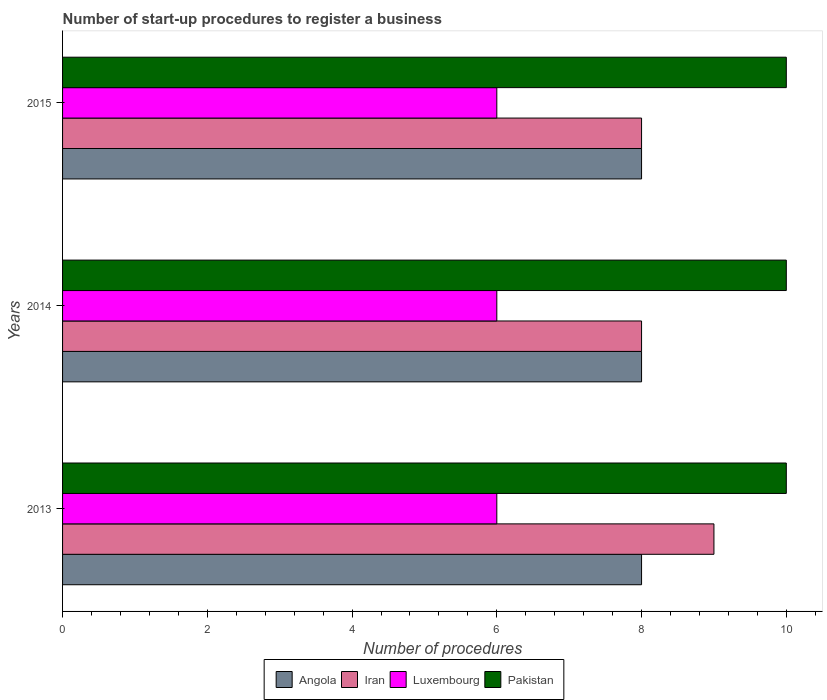How many different coloured bars are there?
Keep it short and to the point. 4. Are the number of bars per tick equal to the number of legend labels?
Your answer should be very brief. Yes. Are the number of bars on each tick of the Y-axis equal?
Offer a terse response. Yes. How many bars are there on the 3rd tick from the top?
Offer a terse response. 4. How many bars are there on the 3rd tick from the bottom?
Make the answer very short. 4. What is the number of procedures required to register a business in Angola in 2013?
Your answer should be compact. 8. Across all years, what is the maximum number of procedures required to register a business in Iran?
Give a very brief answer. 9. Across all years, what is the minimum number of procedures required to register a business in Angola?
Make the answer very short. 8. In which year was the number of procedures required to register a business in Iran maximum?
Your answer should be very brief. 2013. What is the total number of procedures required to register a business in Pakistan in the graph?
Your response must be concise. 30. What is the difference between the number of procedures required to register a business in Angola in 2013 and the number of procedures required to register a business in Pakistan in 2015?
Provide a succinct answer. -2. What is the average number of procedures required to register a business in Angola per year?
Your answer should be compact. 8. In the year 2015, what is the difference between the number of procedures required to register a business in Iran and number of procedures required to register a business in Angola?
Give a very brief answer. 0. In how many years, is the number of procedures required to register a business in Luxembourg greater than 6.8 ?
Your answer should be very brief. 0. Is the number of procedures required to register a business in Angola in 2013 less than that in 2014?
Offer a very short reply. No. What is the difference between the highest and the lowest number of procedures required to register a business in Iran?
Offer a terse response. 1. In how many years, is the number of procedures required to register a business in Angola greater than the average number of procedures required to register a business in Angola taken over all years?
Give a very brief answer. 0. Is the sum of the number of procedures required to register a business in Iran in 2013 and 2014 greater than the maximum number of procedures required to register a business in Luxembourg across all years?
Provide a short and direct response. Yes. What does the 3rd bar from the top in 2015 represents?
Provide a short and direct response. Iran. What does the 3rd bar from the bottom in 2014 represents?
Make the answer very short. Luxembourg. How many bars are there?
Your answer should be very brief. 12. Are all the bars in the graph horizontal?
Your response must be concise. Yes. Are the values on the major ticks of X-axis written in scientific E-notation?
Offer a very short reply. No. Where does the legend appear in the graph?
Your answer should be compact. Bottom center. What is the title of the graph?
Keep it short and to the point. Number of start-up procedures to register a business. Does "Virgin Islands" appear as one of the legend labels in the graph?
Ensure brevity in your answer.  No. What is the label or title of the X-axis?
Make the answer very short. Number of procedures. What is the label or title of the Y-axis?
Your answer should be compact. Years. What is the Number of procedures in Angola in 2013?
Your answer should be compact. 8. What is the Number of procedures in Pakistan in 2014?
Your response must be concise. 10. What is the Number of procedures of Angola in 2015?
Your answer should be compact. 8. Across all years, what is the maximum Number of procedures in Iran?
Give a very brief answer. 9. Across all years, what is the minimum Number of procedures of Angola?
Provide a succinct answer. 8. Across all years, what is the minimum Number of procedures of Iran?
Your response must be concise. 8. Across all years, what is the minimum Number of procedures of Luxembourg?
Provide a succinct answer. 6. What is the difference between the Number of procedures in Iran in 2013 and that in 2014?
Your answer should be very brief. 1. What is the difference between the Number of procedures in Pakistan in 2013 and that in 2014?
Provide a short and direct response. 0. What is the difference between the Number of procedures in Luxembourg in 2013 and that in 2015?
Your response must be concise. 0. What is the difference between the Number of procedures of Pakistan in 2013 and that in 2015?
Provide a succinct answer. 0. What is the difference between the Number of procedures of Luxembourg in 2014 and that in 2015?
Your response must be concise. 0. What is the difference between the Number of procedures in Angola in 2013 and the Number of procedures in Pakistan in 2014?
Your answer should be very brief. -2. What is the difference between the Number of procedures in Iran in 2013 and the Number of procedures in Pakistan in 2014?
Your response must be concise. -1. What is the difference between the Number of procedures of Angola in 2013 and the Number of procedures of Iran in 2015?
Ensure brevity in your answer.  0. What is the difference between the Number of procedures of Angola in 2013 and the Number of procedures of Pakistan in 2015?
Give a very brief answer. -2. What is the difference between the Number of procedures of Luxembourg in 2013 and the Number of procedures of Pakistan in 2015?
Make the answer very short. -4. What is the difference between the Number of procedures of Angola in 2014 and the Number of procedures of Pakistan in 2015?
Offer a terse response. -2. What is the difference between the Number of procedures in Iran in 2014 and the Number of procedures in Luxembourg in 2015?
Your answer should be very brief. 2. What is the average Number of procedures of Angola per year?
Keep it short and to the point. 8. What is the average Number of procedures in Iran per year?
Your answer should be very brief. 8.33. In the year 2013, what is the difference between the Number of procedures of Angola and Number of procedures of Pakistan?
Provide a succinct answer. -2. In the year 2013, what is the difference between the Number of procedures in Iran and Number of procedures in Luxembourg?
Your answer should be very brief. 3. In the year 2013, what is the difference between the Number of procedures in Luxembourg and Number of procedures in Pakistan?
Offer a very short reply. -4. In the year 2014, what is the difference between the Number of procedures of Angola and Number of procedures of Pakistan?
Provide a short and direct response. -2. In the year 2014, what is the difference between the Number of procedures of Iran and Number of procedures of Luxembourg?
Provide a short and direct response. 2. In the year 2014, what is the difference between the Number of procedures in Luxembourg and Number of procedures in Pakistan?
Provide a short and direct response. -4. In the year 2015, what is the difference between the Number of procedures in Angola and Number of procedures in Iran?
Your answer should be compact. 0. In the year 2015, what is the difference between the Number of procedures in Angola and Number of procedures in Pakistan?
Ensure brevity in your answer.  -2. In the year 2015, what is the difference between the Number of procedures in Iran and Number of procedures in Luxembourg?
Provide a short and direct response. 2. In the year 2015, what is the difference between the Number of procedures of Iran and Number of procedures of Pakistan?
Your answer should be compact. -2. In the year 2015, what is the difference between the Number of procedures in Luxembourg and Number of procedures in Pakistan?
Offer a terse response. -4. What is the ratio of the Number of procedures of Angola in 2013 to that in 2014?
Ensure brevity in your answer.  1. What is the ratio of the Number of procedures in Iran in 2013 to that in 2014?
Make the answer very short. 1.12. What is the ratio of the Number of procedures in Luxembourg in 2013 to that in 2014?
Make the answer very short. 1. What is the ratio of the Number of procedures of Pakistan in 2013 to that in 2014?
Offer a very short reply. 1. What is the ratio of the Number of procedures of Angola in 2013 to that in 2015?
Provide a short and direct response. 1. What is the ratio of the Number of procedures in Iran in 2013 to that in 2015?
Offer a terse response. 1.12. What is the ratio of the Number of procedures in Luxembourg in 2013 to that in 2015?
Offer a very short reply. 1. What is the ratio of the Number of procedures of Iran in 2014 to that in 2015?
Offer a very short reply. 1. What is the difference between the highest and the second highest Number of procedures in Angola?
Offer a terse response. 0. What is the difference between the highest and the second highest Number of procedures of Pakistan?
Keep it short and to the point. 0. What is the difference between the highest and the lowest Number of procedures of Iran?
Offer a very short reply. 1. What is the difference between the highest and the lowest Number of procedures in Pakistan?
Make the answer very short. 0. 